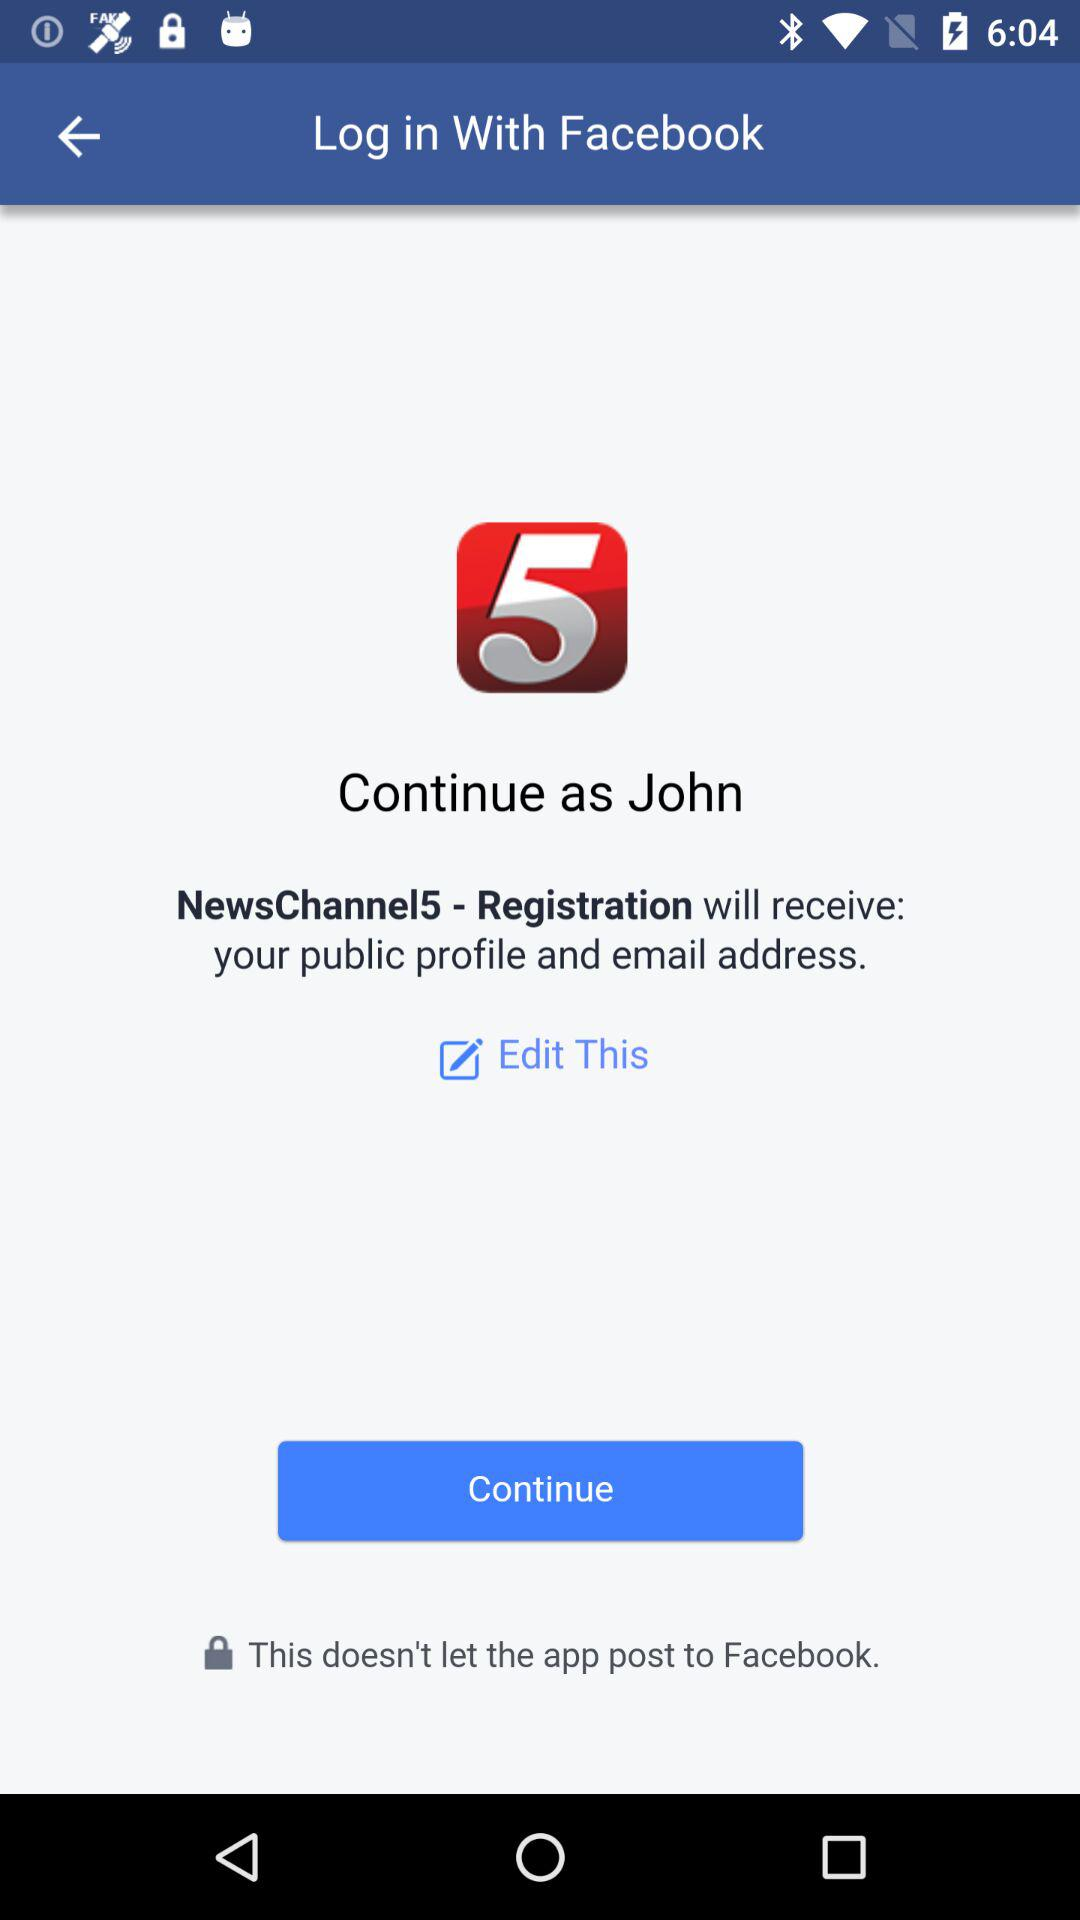Who will receive the public figure and email address? The application is "NewsChannel5 - Registration". 